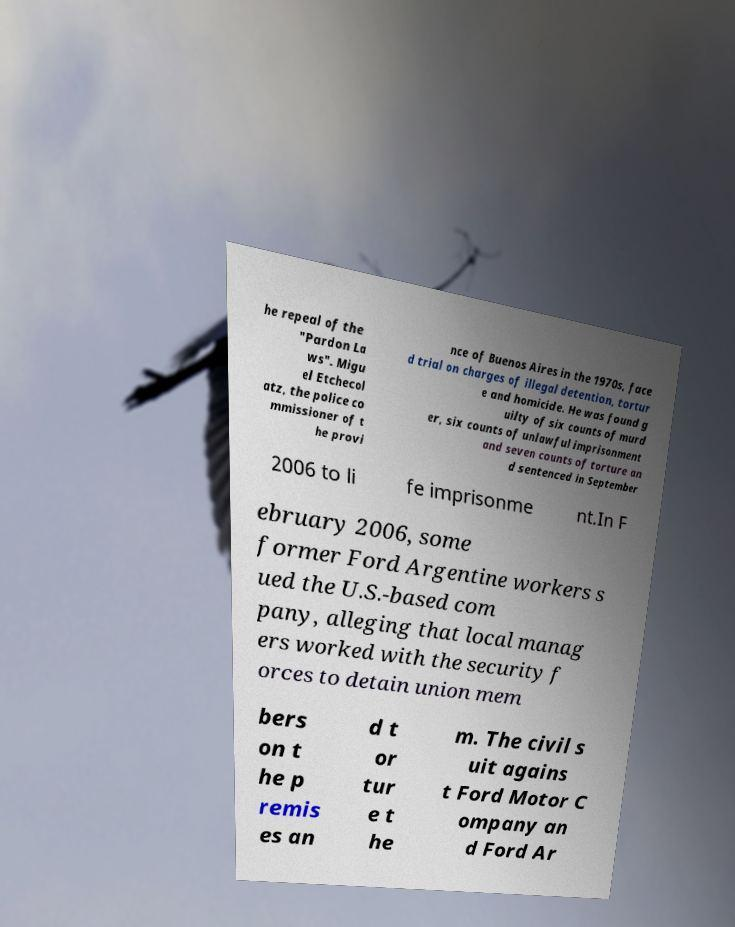There's text embedded in this image that I need extracted. Can you transcribe it verbatim? he repeal of the "Pardon La ws". Migu el Etchecol atz, the police co mmissioner of t he provi nce of Buenos Aires in the 1970s, face d trial on charges of illegal detention, tortur e and homicide. He was found g uilty of six counts of murd er, six counts of unlawful imprisonment and seven counts of torture an d sentenced in September 2006 to li fe imprisonme nt.In F ebruary 2006, some former Ford Argentine workers s ued the U.S.-based com pany, alleging that local manag ers worked with the security f orces to detain union mem bers on t he p remis es an d t or tur e t he m. The civil s uit agains t Ford Motor C ompany an d Ford Ar 